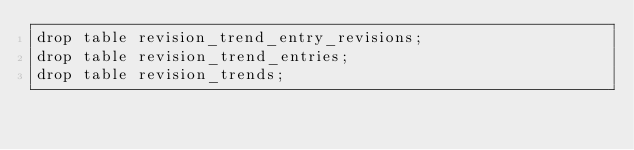<code> <loc_0><loc_0><loc_500><loc_500><_SQL_>drop table revision_trend_entry_revisions;
drop table revision_trend_entries;
drop table revision_trends;</code> 